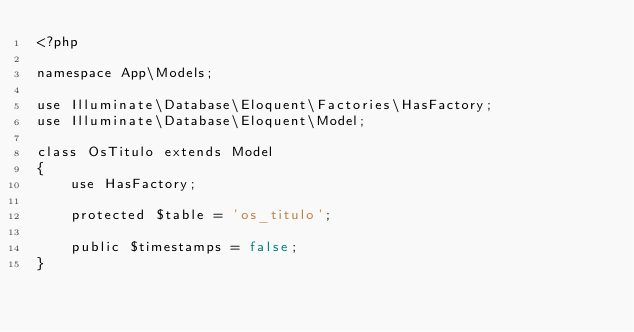Convert code to text. <code><loc_0><loc_0><loc_500><loc_500><_PHP_><?php

namespace App\Models;

use Illuminate\Database\Eloquent\Factories\HasFactory;
use Illuminate\Database\Eloquent\Model;

class OsTitulo extends Model
{
    use HasFactory;

    protected $table = 'os_titulo';

    public $timestamps = false;
}
</code> 